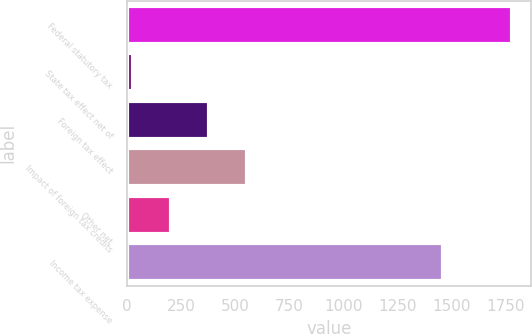Convert chart to OTSL. <chart><loc_0><loc_0><loc_500><loc_500><bar_chart><fcel>Federal statutory tax<fcel>State tax effect net of<fcel>Foreign tax effect<fcel>Impact of foreign tax credits<fcel>Other net<fcel>Income tax expense<nl><fcel>1778<fcel>29<fcel>378.8<fcel>553.7<fcel>203.9<fcel>1462<nl></chart> 